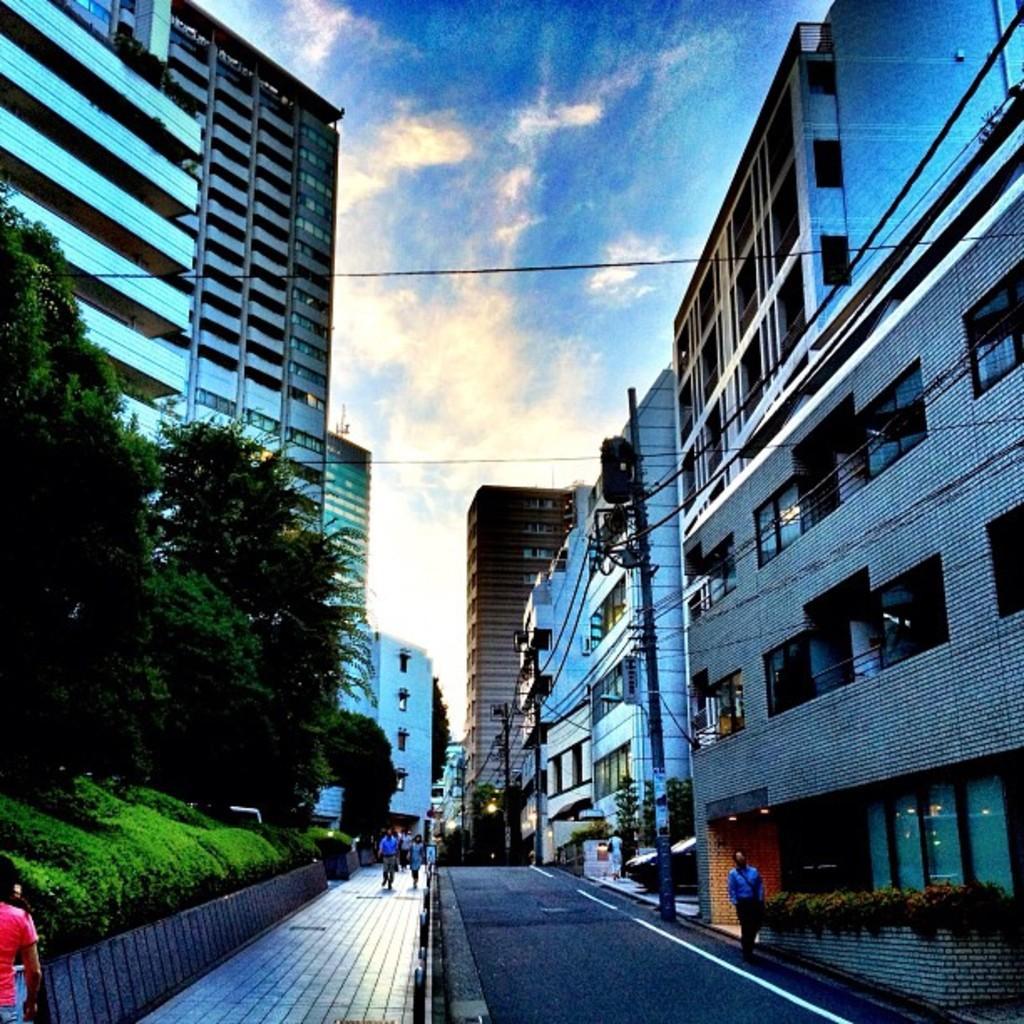How would you summarize this image in a sentence or two? In this image, we can see few buildings, poles, wires, trees, plants. At the bottom, we can see a road, footpath. Few people are walking. Top of the image, there is a sky. 